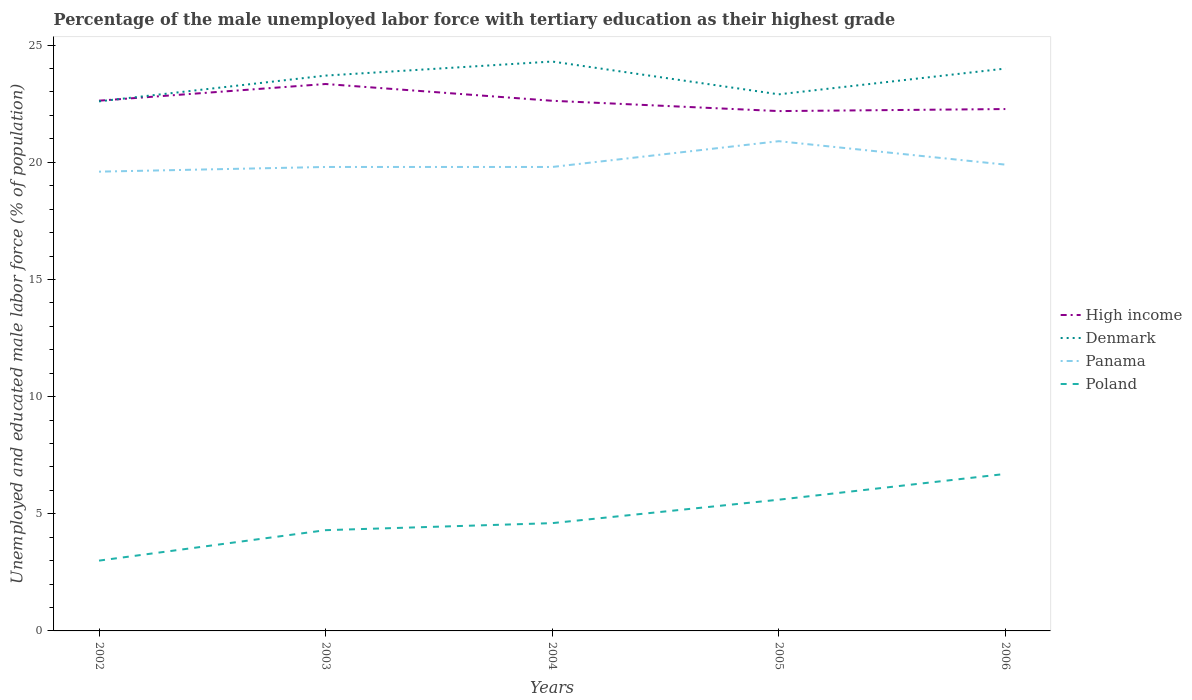How many different coloured lines are there?
Provide a succinct answer. 4. Does the line corresponding to Panama intersect with the line corresponding to High income?
Your answer should be compact. No. Across all years, what is the maximum percentage of the unemployed male labor force with tertiary education in Denmark?
Your response must be concise. 22.6. In which year was the percentage of the unemployed male labor force with tertiary education in Denmark maximum?
Ensure brevity in your answer.  2002. What is the total percentage of the unemployed male labor force with tertiary education in Panama in the graph?
Provide a succinct answer. -1.1. What is the difference between the highest and the second highest percentage of the unemployed male labor force with tertiary education in Panama?
Your answer should be very brief. 1.3. Is the percentage of the unemployed male labor force with tertiary education in High income strictly greater than the percentage of the unemployed male labor force with tertiary education in Poland over the years?
Provide a succinct answer. No. How many years are there in the graph?
Provide a succinct answer. 5. Are the values on the major ticks of Y-axis written in scientific E-notation?
Your response must be concise. No. Does the graph contain grids?
Offer a very short reply. No. How many legend labels are there?
Your response must be concise. 4. How are the legend labels stacked?
Keep it short and to the point. Vertical. What is the title of the graph?
Offer a terse response. Percentage of the male unemployed labor force with tertiary education as their highest grade. What is the label or title of the X-axis?
Your answer should be compact. Years. What is the label or title of the Y-axis?
Provide a succinct answer. Unemployed and educated male labor force (% of population). What is the Unemployed and educated male labor force (% of population) in High income in 2002?
Keep it short and to the point. 22.63. What is the Unemployed and educated male labor force (% of population) of Denmark in 2002?
Provide a succinct answer. 22.6. What is the Unemployed and educated male labor force (% of population) in Panama in 2002?
Your response must be concise. 19.6. What is the Unemployed and educated male labor force (% of population) in High income in 2003?
Offer a terse response. 23.34. What is the Unemployed and educated male labor force (% of population) of Denmark in 2003?
Ensure brevity in your answer.  23.7. What is the Unemployed and educated male labor force (% of population) of Panama in 2003?
Provide a succinct answer. 19.8. What is the Unemployed and educated male labor force (% of population) in Poland in 2003?
Provide a short and direct response. 4.3. What is the Unemployed and educated male labor force (% of population) of High income in 2004?
Ensure brevity in your answer.  22.63. What is the Unemployed and educated male labor force (% of population) in Denmark in 2004?
Your response must be concise. 24.3. What is the Unemployed and educated male labor force (% of population) in Panama in 2004?
Ensure brevity in your answer.  19.8. What is the Unemployed and educated male labor force (% of population) in Poland in 2004?
Keep it short and to the point. 4.6. What is the Unemployed and educated male labor force (% of population) of High income in 2005?
Your answer should be compact. 22.19. What is the Unemployed and educated male labor force (% of population) in Denmark in 2005?
Give a very brief answer. 22.9. What is the Unemployed and educated male labor force (% of population) in Panama in 2005?
Make the answer very short. 20.9. What is the Unemployed and educated male labor force (% of population) in Poland in 2005?
Provide a short and direct response. 5.6. What is the Unemployed and educated male labor force (% of population) of High income in 2006?
Your response must be concise. 22.27. What is the Unemployed and educated male labor force (% of population) in Denmark in 2006?
Your response must be concise. 24. What is the Unemployed and educated male labor force (% of population) of Panama in 2006?
Offer a terse response. 19.9. What is the Unemployed and educated male labor force (% of population) of Poland in 2006?
Offer a very short reply. 6.7. Across all years, what is the maximum Unemployed and educated male labor force (% of population) of High income?
Give a very brief answer. 23.34. Across all years, what is the maximum Unemployed and educated male labor force (% of population) in Denmark?
Offer a terse response. 24.3. Across all years, what is the maximum Unemployed and educated male labor force (% of population) of Panama?
Offer a terse response. 20.9. Across all years, what is the maximum Unemployed and educated male labor force (% of population) in Poland?
Ensure brevity in your answer.  6.7. Across all years, what is the minimum Unemployed and educated male labor force (% of population) in High income?
Keep it short and to the point. 22.19. Across all years, what is the minimum Unemployed and educated male labor force (% of population) of Denmark?
Offer a terse response. 22.6. Across all years, what is the minimum Unemployed and educated male labor force (% of population) in Panama?
Offer a terse response. 19.6. Across all years, what is the minimum Unemployed and educated male labor force (% of population) of Poland?
Your answer should be compact. 3. What is the total Unemployed and educated male labor force (% of population) of High income in the graph?
Your answer should be compact. 113.05. What is the total Unemployed and educated male labor force (% of population) of Denmark in the graph?
Your answer should be very brief. 117.5. What is the total Unemployed and educated male labor force (% of population) of Panama in the graph?
Ensure brevity in your answer.  100. What is the total Unemployed and educated male labor force (% of population) of Poland in the graph?
Provide a succinct answer. 24.2. What is the difference between the Unemployed and educated male labor force (% of population) of High income in 2002 and that in 2003?
Give a very brief answer. -0.71. What is the difference between the Unemployed and educated male labor force (% of population) in Denmark in 2002 and that in 2003?
Your answer should be compact. -1.1. What is the difference between the Unemployed and educated male labor force (% of population) of High income in 2002 and that in 2004?
Ensure brevity in your answer.  0. What is the difference between the Unemployed and educated male labor force (% of population) in Denmark in 2002 and that in 2004?
Make the answer very short. -1.7. What is the difference between the Unemployed and educated male labor force (% of population) of Panama in 2002 and that in 2004?
Provide a succinct answer. -0.2. What is the difference between the Unemployed and educated male labor force (% of population) in Poland in 2002 and that in 2004?
Provide a succinct answer. -1.6. What is the difference between the Unemployed and educated male labor force (% of population) in High income in 2002 and that in 2005?
Your answer should be very brief. 0.44. What is the difference between the Unemployed and educated male labor force (% of population) of Denmark in 2002 and that in 2005?
Offer a terse response. -0.3. What is the difference between the Unemployed and educated male labor force (% of population) of Panama in 2002 and that in 2005?
Make the answer very short. -1.3. What is the difference between the Unemployed and educated male labor force (% of population) in High income in 2002 and that in 2006?
Give a very brief answer. 0.36. What is the difference between the Unemployed and educated male labor force (% of population) of Panama in 2002 and that in 2006?
Offer a very short reply. -0.3. What is the difference between the Unemployed and educated male labor force (% of population) of Poland in 2002 and that in 2006?
Give a very brief answer. -3.7. What is the difference between the Unemployed and educated male labor force (% of population) in High income in 2003 and that in 2004?
Your response must be concise. 0.72. What is the difference between the Unemployed and educated male labor force (% of population) of Denmark in 2003 and that in 2004?
Provide a short and direct response. -0.6. What is the difference between the Unemployed and educated male labor force (% of population) in Poland in 2003 and that in 2004?
Ensure brevity in your answer.  -0.3. What is the difference between the Unemployed and educated male labor force (% of population) of High income in 2003 and that in 2005?
Give a very brief answer. 1.16. What is the difference between the Unemployed and educated male labor force (% of population) in Poland in 2003 and that in 2005?
Your answer should be compact. -1.3. What is the difference between the Unemployed and educated male labor force (% of population) of High income in 2003 and that in 2006?
Provide a succinct answer. 1.07. What is the difference between the Unemployed and educated male labor force (% of population) of Denmark in 2003 and that in 2006?
Keep it short and to the point. -0.3. What is the difference between the Unemployed and educated male labor force (% of population) in Poland in 2003 and that in 2006?
Make the answer very short. -2.4. What is the difference between the Unemployed and educated male labor force (% of population) of High income in 2004 and that in 2005?
Keep it short and to the point. 0.44. What is the difference between the Unemployed and educated male labor force (% of population) in Denmark in 2004 and that in 2005?
Your answer should be very brief. 1.4. What is the difference between the Unemployed and educated male labor force (% of population) in Panama in 2004 and that in 2005?
Your answer should be compact. -1.1. What is the difference between the Unemployed and educated male labor force (% of population) in High income in 2004 and that in 2006?
Offer a terse response. 0.35. What is the difference between the Unemployed and educated male labor force (% of population) of Denmark in 2004 and that in 2006?
Ensure brevity in your answer.  0.3. What is the difference between the Unemployed and educated male labor force (% of population) of High income in 2005 and that in 2006?
Make the answer very short. -0.09. What is the difference between the Unemployed and educated male labor force (% of population) of Panama in 2005 and that in 2006?
Provide a short and direct response. 1. What is the difference between the Unemployed and educated male labor force (% of population) of Poland in 2005 and that in 2006?
Offer a very short reply. -1.1. What is the difference between the Unemployed and educated male labor force (% of population) in High income in 2002 and the Unemployed and educated male labor force (% of population) in Denmark in 2003?
Ensure brevity in your answer.  -1.07. What is the difference between the Unemployed and educated male labor force (% of population) in High income in 2002 and the Unemployed and educated male labor force (% of population) in Panama in 2003?
Your answer should be compact. 2.83. What is the difference between the Unemployed and educated male labor force (% of population) in High income in 2002 and the Unemployed and educated male labor force (% of population) in Poland in 2003?
Give a very brief answer. 18.33. What is the difference between the Unemployed and educated male labor force (% of population) in Panama in 2002 and the Unemployed and educated male labor force (% of population) in Poland in 2003?
Your response must be concise. 15.3. What is the difference between the Unemployed and educated male labor force (% of population) in High income in 2002 and the Unemployed and educated male labor force (% of population) in Denmark in 2004?
Your answer should be very brief. -1.67. What is the difference between the Unemployed and educated male labor force (% of population) of High income in 2002 and the Unemployed and educated male labor force (% of population) of Panama in 2004?
Offer a very short reply. 2.83. What is the difference between the Unemployed and educated male labor force (% of population) of High income in 2002 and the Unemployed and educated male labor force (% of population) of Poland in 2004?
Give a very brief answer. 18.03. What is the difference between the Unemployed and educated male labor force (% of population) in Denmark in 2002 and the Unemployed and educated male labor force (% of population) in Panama in 2004?
Ensure brevity in your answer.  2.8. What is the difference between the Unemployed and educated male labor force (% of population) of High income in 2002 and the Unemployed and educated male labor force (% of population) of Denmark in 2005?
Provide a short and direct response. -0.27. What is the difference between the Unemployed and educated male labor force (% of population) of High income in 2002 and the Unemployed and educated male labor force (% of population) of Panama in 2005?
Offer a very short reply. 1.73. What is the difference between the Unemployed and educated male labor force (% of population) in High income in 2002 and the Unemployed and educated male labor force (% of population) in Poland in 2005?
Provide a short and direct response. 17.03. What is the difference between the Unemployed and educated male labor force (% of population) in Denmark in 2002 and the Unemployed and educated male labor force (% of population) in Poland in 2005?
Give a very brief answer. 17. What is the difference between the Unemployed and educated male labor force (% of population) in Panama in 2002 and the Unemployed and educated male labor force (% of population) in Poland in 2005?
Ensure brevity in your answer.  14. What is the difference between the Unemployed and educated male labor force (% of population) in High income in 2002 and the Unemployed and educated male labor force (% of population) in Denmark in 2006?
Your answer should be very brief. -1.37. What is the difference between the Unemployed and educated male labor force (% of population) in High income in 2002 and the Unemployed and educated male labor force (% of population) in Panama in 2006?
Provide a short and direct response. 2.73. What is the difference between the Unemployed and educated male labor force (% of population) in High income in 2002 and the Unemployed and educated male labor force (% of population) in Poland in 2006?
Offer a terse response. 15.93. What is the difference between the Unemployed and educated male labor force (% of population) of Denmark in 2002 and the Unemployed and educated male labor force (% of population) of Poland in 2006?
Provide a succinct answer. 15.9. What is the difference between the Unemployed and educated male labor force (% of population) of Panama in 2002 and the Unemployed and educated male labor force (% of population) of Poland in 2006?
Offer a very short reply. 12.9. What is the difference between the Unemployed and educated male labor force (% of population) in High income in 2003 and the Unemployed and educated male labor force (% of population) in Denmark in 2004?
Your answer should be very brief. -0.96. What is the difference between the Unemployed and educated male labor force (% of population) in High income in 2003 and the Unemployed and educated male labor force (% of population) in Panama in 2004?
Offer a very short reply. 3.54. What is the difference between the Unemployed and educated male labor force (% of population) of High income in 2003 and the Unemployed and educated male labor force (% of population) of Poland in 2004?
Provide a short and direct response. 18.74. What is the difference between the Unemployed and educated male labor force (% of population) of Denmark in 2003 and the Unemployed and educated male labor force (% of population) of Poland in 2004?
Ensure brevity in your answer.  19.1. What is the difference between the Unemployed and educated male labor force (% of population) in High income in 2003 and the Unemployed and educated male labor force (% of population) in Denmark in 2005?
Provide a succinct answer. 0.44. What is the difference between the Unemployed and educated male labor force (% of population) in High income in 2003 and the Unemployed and educated male labor force (% of population) in Panama in 2005?
Offer a terse response. 2.44. What is the difference between the Unemployed and educated male labor force (% of population) of High income in 2003 and the Unemployed and educated male labor force (% of population) of Poland in 2005?
Keep it short and to the point. 17.74. What is the difference between the Unemployed and educated male labor force (% of population) in Denmark in 2003 and the Unemployed and educated male labor force (% of population) in Panama in 2005?
Ensure brevity in your answer.  2.8. What is the difference between the Unemployed and educated male labor force (% of population) in Panama in 2003 and the Unemployed and educated male labor force (% of population) in Poland in 2005?
Provide a succinct answer. 14.2. What is the difference between the Unemployed and educated male labor force (% of population) of High income in 2003 and the Unemployed and educated male labor force (% of population) of Denmark in 2006?
Your answer should be compact. -0.66. What is the difference between the Unemployed and educated male labor force (% of population) of High income in 2003 and the Unemployed and educated male labor force (% of population) of Panama in 2006?
Your answer should be very brief. 3.44. What is the difference between the Unemployed and educated male labor force (% of population) in High income in 2003 and the Unemployed and educated male labor force (% of population) in Poland in 2006?
Provide a short and direct response. 16.64. What is the difference between the Unemployed and educated male labor force (% of population) of Denmark in 2003 and the Unemployed and educated male labor force (% of population) of Poland in 2006?
Keep it short and to the point. 17. What is the difference between the Unemployed and educated male labor force (% of population) of Panama in 2003 and the Unemployed and educated male labor force (% of population) of Poland in 2006?
Give a very brief answer. 13.1. What is the difference between the Unemployed and educated male labor force (% of population) of High income in 2004 and the Unemployed and educated male labor force (% of population) of Denmark in 2005?
Provide a short and direct response. -0.27. What is the difference between the Unemployed and educated male labor force (% of population) in High income in 2004 and the Unemployed and educated male labor force (% of population) in Panama in 2005?
Make the answer very short. 1.73. What is the difference between the Unemployed and educated male labor force (% of population) in High income in 2004 and the Unemployed and educated male labor force (% of population) in Poland in 2005?
Make the answer very short. 17.03. What is the difference between the Unemployed and educated male labor force (% of population) in Denmark in 2004 and the Unemployed and educated male labor force (% of population) in Panama in 2005?
Offer a terse response. 3.4. What is the difference between the Unemployed and educated male labor force (% of population) in Panama in 2004 and the Unemployed and educated male labor force (% of population) in Poland in 2005?
Offer a terse response. 14.2. What is the difference between the Unemployed and educated male labor force (% of population) in High income in 2004 and the Unemployed and educated male labor force (% of population) in Denmark in 2006?
Your answer should be very brief. -1.37. What is the difference between the Unemployed and educated male labor force (% of population) in High income in 2004 and the Unemployed and educated male labor force (% of population) in Panama in 2006?
Your answer should be very brief. 2.73. What is the difference between the Unemployed and educated male labor force (% of population) of High income in 2004 and the Unemployed and educated male labor force (% of population) of Poland in 2006?
Give a very brief answer. 15.93. What is the difference between the Unemployed and educated male labor force (% of population) in High income in 2005 and the Unemployed and educated male labor force (% of population) in Denmark in 2006?
Offer a terse response. -1.81. What is the difference between the Unemployed and educated male labor force (% of population) of High income in 2005 and the Unemployed and educated male labor force (% of population) of Panama in 2006?
Ensure brevity in your answer.  2.29. What is the difference between the Unemployed and educated male labor force (% of population) of High income in 2005 and the Unemployed and educated male labor force (% of population) of Poland in 2006?
Give a very brief answer. 15.48. What is the difference between the Unemployed and educated male labor force (% of population) of Denmark in 2005 and the Unemployed and educated male labor force (% of population) of Panama in 2006?
Offer a terse response. 3. What is the difference between the Unemployed and educated male labor force (% of population) of Denmark in 2005 and the Unemployed and educated male labor force (% of population) of Poland in 2006?
Keep it short and to the point. 16.2. What is the average Unemployed and educated male labor force (% of population) of High income per year?
Make the answer very short. 22.61. What is the average Unemployed and educated male labor force (% of population) in Poland per year?
Provide a short and direct response. 4.84. In the year 2002, what is the difference between the Unemployed and educated male labor force (% of population) of High income and Unemployed and educated male labor force (% of population) of Denmark?
Make the answer very short. 0.03. In the year 2002, what is the difference between the Unemployed and educated male labor force (% of population) in High income and Unemployed and educated male labor force (% of population) in Panama?
Ensure brevity in your answer.  3.03. In the year 2002, what is the difference between the Unemployed and educated male labor force (% of population) in High income and Unemployed and educated male labor force (% of population) in Poland?
Offer a very short reply. 19.63. In the year 2002, what is the difference between the Unemployed and educated male labor force (% of population) of Denmark and Unemployed and educated male labor force (% of population) of Panama?
Give a very brief answer. 3. In the year 2002, what is the difference between the Unemployed and educated male labor force (% of population) of Denmark and Unemployed and educated male labor force (% of population) of Poland?
Offer a terse response. 19.6. In the year 2002, what is the difference between the Unemployed and educated male labor force (% of population) of Panama and Unemployed and educated male labor force (% of population) of Poland?
Offer a very short reply. 16.6. In the year 2003, what is the difference between the Unemployed and educated male labor force (% of population) of High income and Unemployed and educated male labor force (% of population) of Denmark?
Your response must be concise. -0.36. In the year 2003, what is the difference between the Unemployed and educated male labor force (% of population) in High income and Unemployed and educated male labor force (% of population) in Panama?
Provide a short and direct response. 3.54. In the year 2003, what is the difference between the Unemployed and educated male labor force (% of population) of High income and Unemployed and educated male labor force (% of population) of Poland?
Offer a very short reply. 19.04. In the year 2003, what is the difference between the Unemployed and educated male labor force (% of population) in Denmark and Unemployed and educated male labor force (% of population) in Poland?
Offer a very short reply. 19.4. In the year 2003, what is the difference between the Unemployed and educated male labor force (% of population) in Panama and Unemployed and educated male labor force (% of population) in Poland?
Offer a terse response. 15.5. In the year 2004, what is the difference between the Unemployed and educated male labor force (% of population) of High income and Unemployed and educated male labor force (% of population) of Denmark?
Your answer should be very brief. -1.67. In the year 2004, what is the difference between the Unemployed and educated male labor force (% of population) in High income and Unemployed and educated male labor force (% of population) in Panama?
Your answer should be very brief. 2.83. In the year 2004, what is the difference between the Unemployed and educated male labor force (% of population) in High income and Unemployed and educated male labor force (% of population) in Poland?
Your answer should be very brief. 18.03. In the year 2004, what is the difference between the Unemployed and educated male labor force (% of population) of Denmark and Unemployed and educated male labor force (% of population) of Poland?
Offer a terse response. 19.7. In the year 2005, what is the difference between the Unemployed and educated male labor force (% of population) in High income and Unemployed and educated male labor force (% of population) in Denmark?
Make the answer very short. -0.71. In the year 2005, what is the difference between the Unemployed and educated male labor force (% of population) in High income and Unemployed and educated male labor force (% of population) in Panama?
Your response must be concise. 1.28. In the year 2005, what is the difference between the Unemployed and educated male labor force (% of population) of High income and Unemployed and educated male labor force (% of population) of Poland?
Your response must be concise. 16.59. In the year 2005, what is the difference between the Unemployed and educated male labor force (% of population) of Denmark and Unemployed and educated male labor force (% of population) of Panama?
Provide a short and direct response. 2. In the year 2005, what is the difference between the Unemployed and educated male labor force (% of population) of Denmark and Unemployed and educated male labor force (% of population) of Poland?
Keep it short and to the point. 17.3. In the year 2005, what is the difference between the Unemployed and educated male labor force (% of population) in Panama and Unemployed and educated male labor force (% of population) in Poland?
Your answer should be very brief. 15.3. In the year 2006, what is the difference between the Unemployed and educated male labor force (% of population) of High income and Unemployed and educated male labor force (% of population) of Denmark?
Make the answer very short. -1.73. In the year 2006, what is the difference between the Unemployed and educated male labor force (% of population) in High income and Unemployed and educated male labor force (% of population) in Panama?
Make the answer very short. 2.37. In the year 2006, what is the difference between the Unemployed and educated male labor force (% of population) in High income and Unemployed and educated male labor force (% of population) in Poland?
Give a very brief answer. 15.57. In the year 2006, what is the difference between the Unemployed and educated male labor force (% of population) of Denmark and Unemployed and educated male labor force (% of population) of Panama?
Offer a very short reply. 4.1. In the year 2006, what is the difference between the Unemployed and educated male labor force (% of population) of Denmark and Unemployed and educated male labor force (% of population) of Poland?
Provide a short and direct response. 17.3. In the year 2006, what is the difference between the Unemployed and educated male labor force (% of population) in Panama and Unemployed and educated male labor force (% of population) in Poland?
Your answer should be compact. 13.2. What is the ratio of the Unemployed and educated male labor force (% of population) of High income in 2002 to that in 2003?
Ensure brevity in your answer.  0.97. What is the ratio of the Unemployed and educated male labor force (% of population) of Denmark in 2002 to that in 2003?
Keep it short and to the point. 0.95. What is the ratio of the Unemployed and educated male labor force (% of population) in Poland in 2002 to that in 2003?
Your answer should be very brief. 0.7. What is the ratio of the Unemployed and educated male labor force (% of population) of Denmark in 2002 to that in 2004?
Ensure brevity in your answer.  0.93. What is the ratio of the Unemployed and educated male labor force (% of population) of Panama in 2002 to that in 2004?
Keep it short and to the point. 0.99. What is the ratio of the Unemployed and educated male labor force (% of population) in Poland in 2002 to that in 2004?
Provide a succinct answer. 0.65. What is the ratio of the Unemployed and educated male labor force (% of population) of Denmark in 2002 to that in 2005?
Make the answer very short. 0.99. What is the ratio of the Unemployed and educated male labor force (% of population) in Panama in 2002 to that in 2005?
Make the answer very short. 0.94. What is the ratio of the Unemployed and educated male labor force (% of population) in Poland in 2002 to that in 2005?
Ensure brevity in your answer.  0.54. What is the ratio of the Unemployed and educated male labor force (% of population) in Denmark in 2002 to that in 2006?
Your answer should be compact. 0.94. What is the ratio of the Unemployed and educated male labor force (% of population) in Panama in 2002 to that in 2006?
Make the answer very short. 0.98. What is the ratio of the Unemployed and educated male labor force (% of population) in Poland in 2002 to that in 2006?
Offer a very short reply. 0.45. What is the ratio of the Unemployed and educated male labor force (% of population) of High income in 2003 to that in 2004?
Offer a terse response. 1.03. What is the ratio of the Unemployed and educated male labor force (% of population) of Denmark in 2003 to that in 2004?
Make the answer very short. 0.98. What is the ratio of the Unemployed and educated male labor force (% of population) of Poland in 2003 to that in 2004?
Your answer should be very brief. 0.93. What is the ratio of the Unemployed and educated male labor force (% of population) of High income in 2003 to that in 2005?
Your answer should be very brief. 1.05. What is the ratio of the Unemployed and educated male labor force (% of population) of Denmark in 2003 to that in 2005?
Give a very brief answer. 1.03. What is the ratio of the Unemployed and educated male labor force (% of population) in Poland in 2003 to that in 2005?
Provide a succinct answer. 0.77. What is the ratio of the Unemployed and educated male labor force (% of population) of High income in 2003 to that in 2006?
Provide a short and direct response. 1.05. What is the ratio of the Unemployed and educated male labor force (% of population) in Denmark in 2003 to that in 2006?
Offer a very short reply. 0.99. What is the ratio of the Unemployed and educated male labor force (% of population) of Panama in 2003 to that in 2006?
Give a very brief answer. 0.99. What is the ratio of the Unemployed and educated male labor force (% of population) in Poland in 2003 to that in 2006?
Ensure brevity in your answer.  0.64. What is the ratio of the Unemployed and educated male labor force (% of population) in High income in 2004 to that in 2005?
Your answer should be very brief. 1.02. What is the ratio of the Unemployed and educated male labor force (% of population) of Denmark in 2004 to that in 2005?
Offer a terse response. 1.06. What is the ratio of the Unemployed and educated male labor force (% of population) in Panama in 2004 to that in 2005?
Offer a terse response. 0.95. What is the ratio of the Unemployed and educated male labor force (% of population) of Poland in 2004 to that in 2005?
Give a very brief answer. 0.82. What is the ratio of the Unemployed and educated male labor force (% of population) in High income in 2004 to that in 2006?
Offer a very short reply. 1.02. What is the ratio of the Unemployed and educated male labor force (% of population) in Denmark in 2004 to that in 2006?
Your answer should be very brief. 1.01. What is the ratio of the Unemployed and educated male labor force (% of population) of Panama in 2004 to that in 2006?
Ensure brevity in your answer.  0.99. What is the ratio of the Unemployed and educated male labor force (% of population) in Poland in 2004 to that in 2006?
Offer a very short reply. 0.69. What is the ratio of the Unemployed and educated male labor force (% of population) in Denmark in 2005 to that in 2006?
Your response must be concise. 0.95. What is the ratio of the Unemployed and educated male labor force (% of population) of Panama in 2005 to that in 2006?
Ensure brevity in your answer.  1.05. What is the ratio of the Unemployed and educated male labor force (% of population) in Poland in 2005 to that in 2006?
Offer a very short reply. 0.84. What is the difference between the highest and the second highest Unemployed and educated male labor force (% of population) in High income?
Your answer should be very brief. 0.71. What is the difference between the highest and the second highest Unemployed and educated male labor force (% of population) in Panama?
Give a very brief answer. 1. What is the difference between the highest and the second highest Unemployed and educated male labor force (% of population) of Poland?
Provide a succinct answer. 1.1. What is the difference between the highest and the lowest Unemployed and educated male labor force (% of population) of High income?
Your response must be concise. 1.16. 